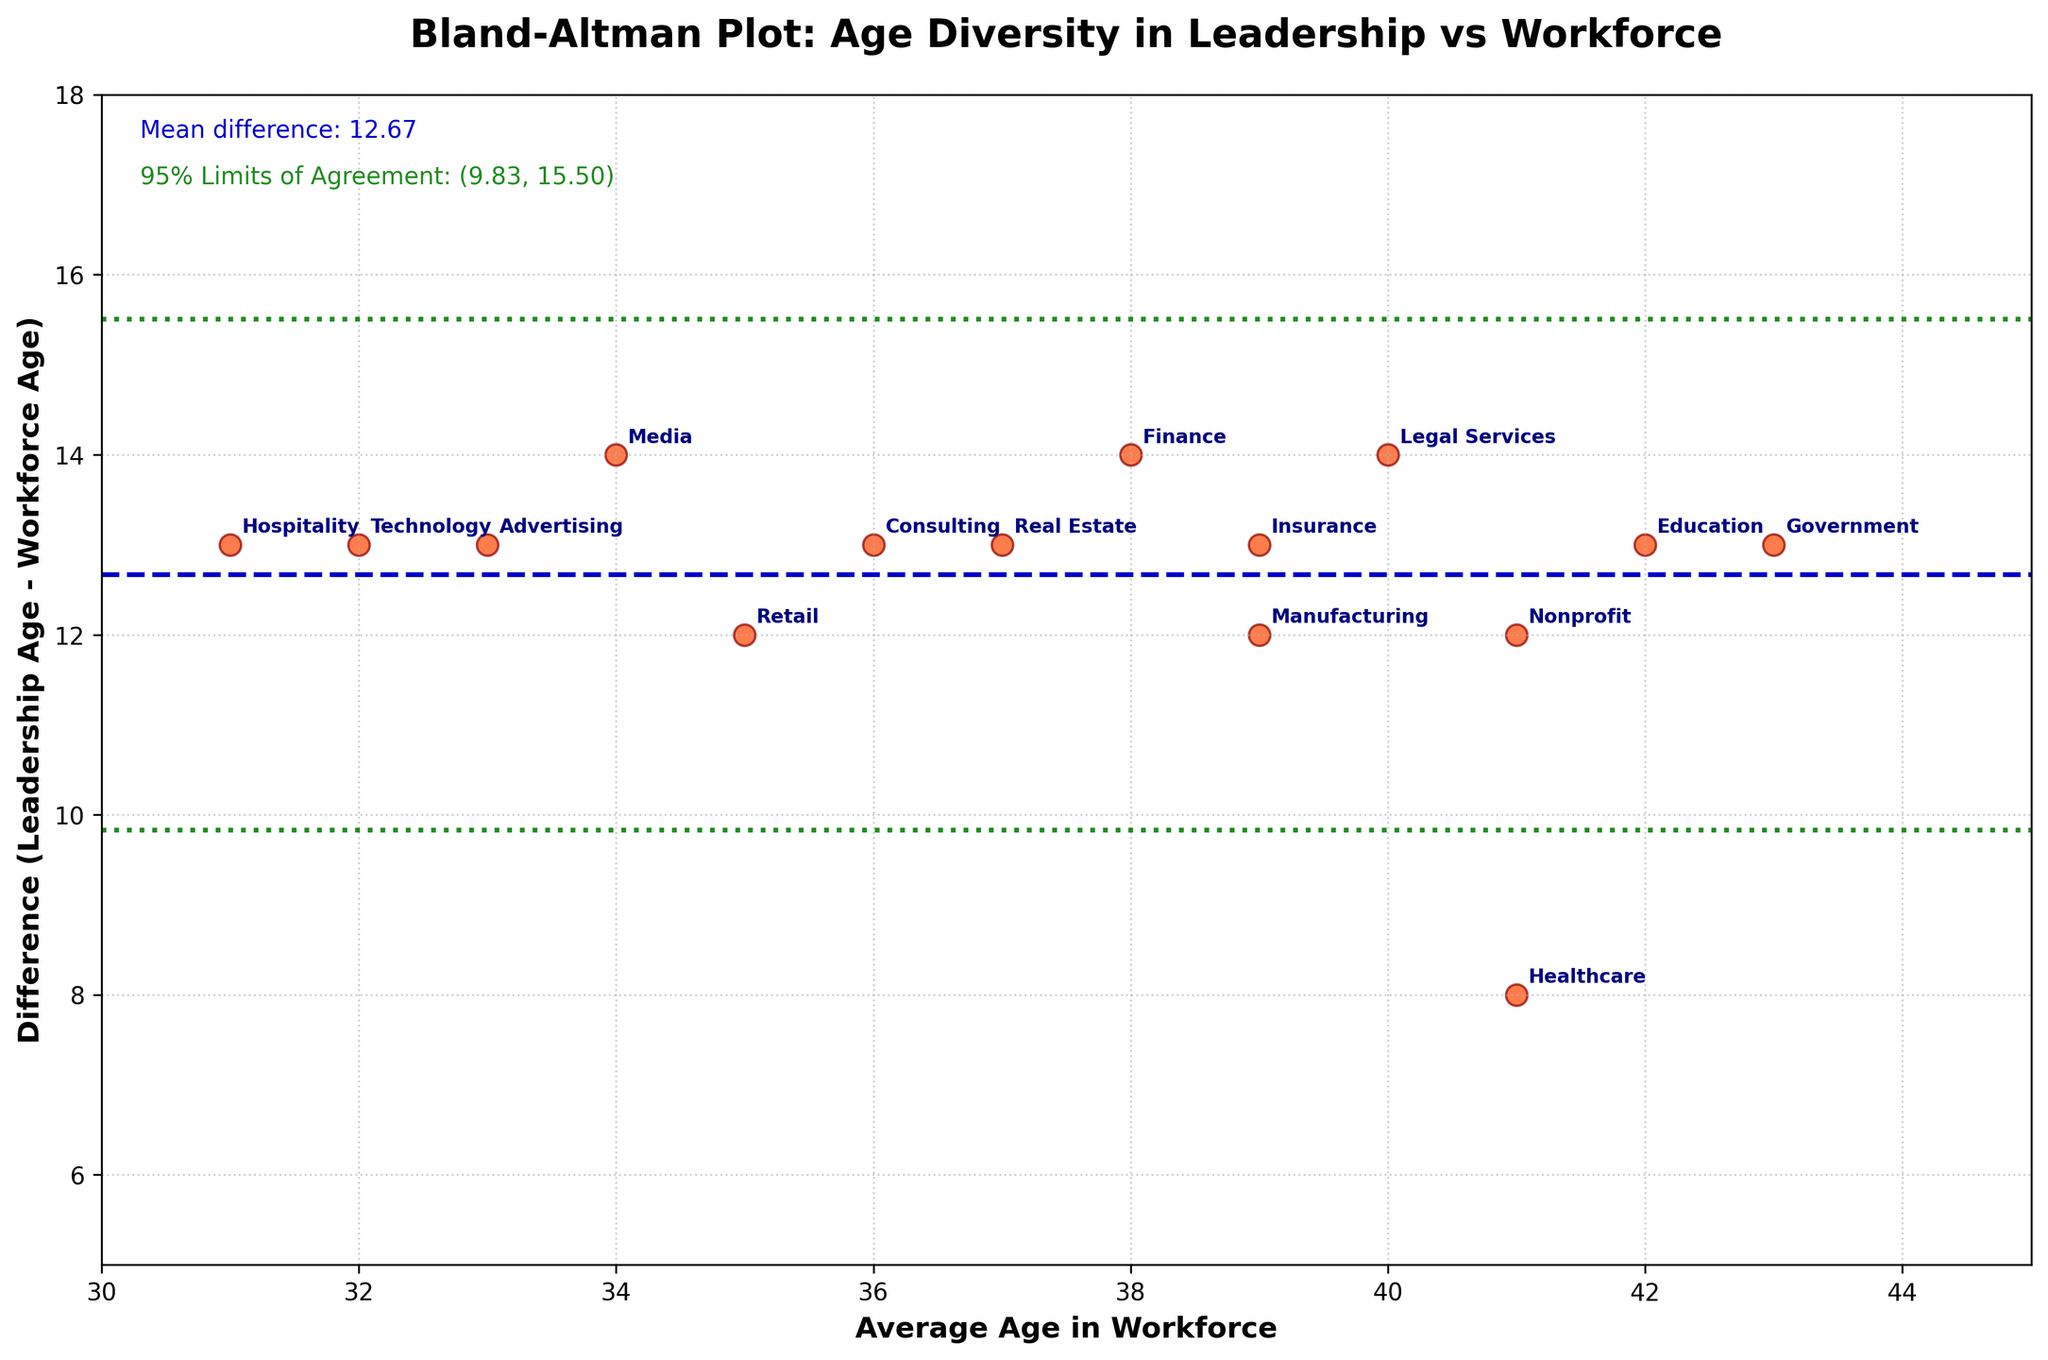what is the title of the plot? The title of the plot is clearly shown at the top and reads "Bland-Altman Plot: Age Diversity in Leadership vs Workforce."
Answer: Bland-Altman Plot: Age Diversity in Leadership vs Workforce How many data points are there on the plot? Each data point corresponds to an industry, and we see labeled industries for each point. There are 15 different labels.
Answer: 15 What is the mean difference of age between leadership and workforce? The mean difference is specifically marked by a horizontal line and listed in text on the plot. The text reads "Mean difference: 12.87."
Answer: 12.87 What are the 95% Limits of Agreement? The 95% Limits of Agreement are shown as two horizontal lines in green and mentioned in the text. The text reads "95% Limits of Agreement: (8.96, 16.79)."
Answer: (8.96, 16.79) Which industry shows the largest age difference between leadership and workforce? By observing the y-values, Media, Finance, and Legal Services appear at the highest points. The label near the highest point at y=14 is "Media," which has the largest difference.
Answer: Media Which industry has the smallest age difference between leadership and workforce? From the y-values, Healthcare has the lowest difference at y=8, as indicated by its label.
Answer: Healthcare Does the average workforce age correlate to the age difference between leadership and workforce? By looking at the scatter plot, we determine if there's a visible pattern. The points do not show a strong correlation where the x-values (workforce age) relate to the y-values (age difference).
Answer: No What is the approximate age difference for the industry with an average workforce age of 35? The point with x=35 corresponds to Retail. The y-value (difference) for this point reads approximately 12.
Answer: 12 Which industry has an average workforce age closest to 37 years? By comparing x-values, Real Estate has an average workforce age closest to 37 years, as shown by its label.
Answer: Real Estate 